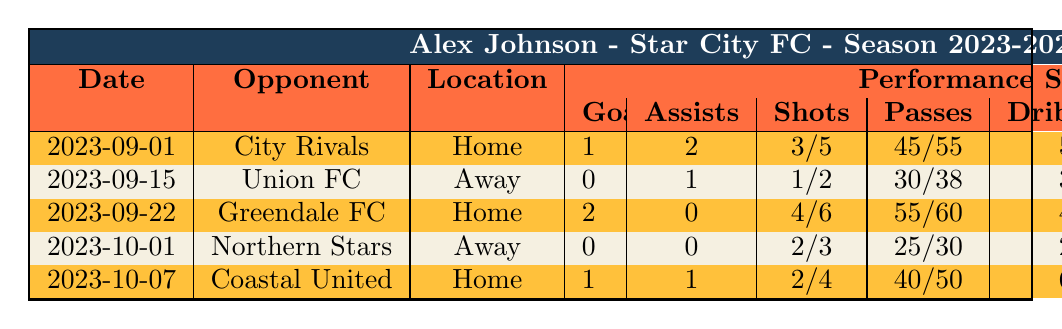What was Alex Johnson's best performance in terms of goals scored? The match against Greendale FC on 2023-09-22 is Alex Johnson's best performance as he scored 2 goals in that match, which is the highest compared to other matches listed.
Answer: 2 goals In how many matches did Alex Johnson provide assists? Alex Johnson provided assists in 3 matches: 2 assists against City Rivals, 1 assist against Union FC, and 1 against Coastal United, which totals to 4 assists.
Answer: 4 assists What is the total number of shots on target Alex Johnson had in the season so far? Summing up his shots on target across all matches: 3 (City Rivals) + 1 (Union FC) + 4 (Greendale FC) + 2 (Northern Stars) + 2 (Coastal United) equals 12 shots on target.
Answer: 12 shots on target Did Alex Johnson receive any red cards? Alex Johnson received 1 red card in the match against Northern Stars on 2023-10-01.
Answer: Yes What is the average number of goals scored per match by Alex Johnson? Alex Johnson scored a total of 4 goals in 5 matches. To find the average, we divide the total goals (4) by the number of matches (5), which gives an average of 0.8 goals per match.
Answer: 0.8 goals per match How many total passes did Alex complete against Greendale FC? Referring to the match against Greendale FC, Alex Johnson completed 55 passes, which is the total passes that he made in that match.
Answer: 55 passes In which match did Alex Johnson commit the most fouls? He committed the most fouls (2) in the match against Union FC on 2023-09-15. This can be determined by comparing the fouls committed in each match listed.
Answer: Union FC match What was the highest number of dribbles completed by Alex Johnson in a single match? Alex Johnson completed the highest number of dribbles (6) in the match against Coastal United on 2023-10-07, compared to other matches listed.
Answer: 6 dribbles What is the difference between the total shots and the shots on target in the match against City Rivals? In this match, Alex Johnson took 5 total shots and had 3 shots on target. The difference is calculated by subtracting the shots on target from total shots: 5 - 3 = 2.
Answer: 2 What percentage of passes did Alex Johnson complete in the match against Northern Stars? Alex completed 25 passes out of 30 total passes in the match against Northern Stars. To find the percentage, (25 completed passes / 30 total passes) * 100 = 83.33%.
Answer: 83.33% 